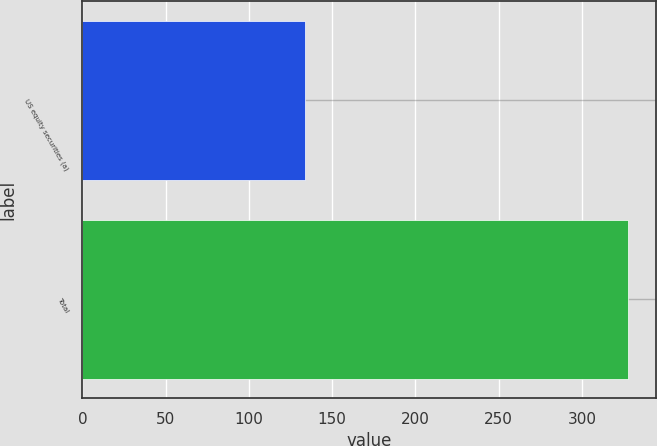<chart> <loc_0><loc_0><loc_500><loc_500><bar_chart><fcel>US equity securities (a)<fcel>Total<nl><fcel>134<fcel>328<nl></chart> 